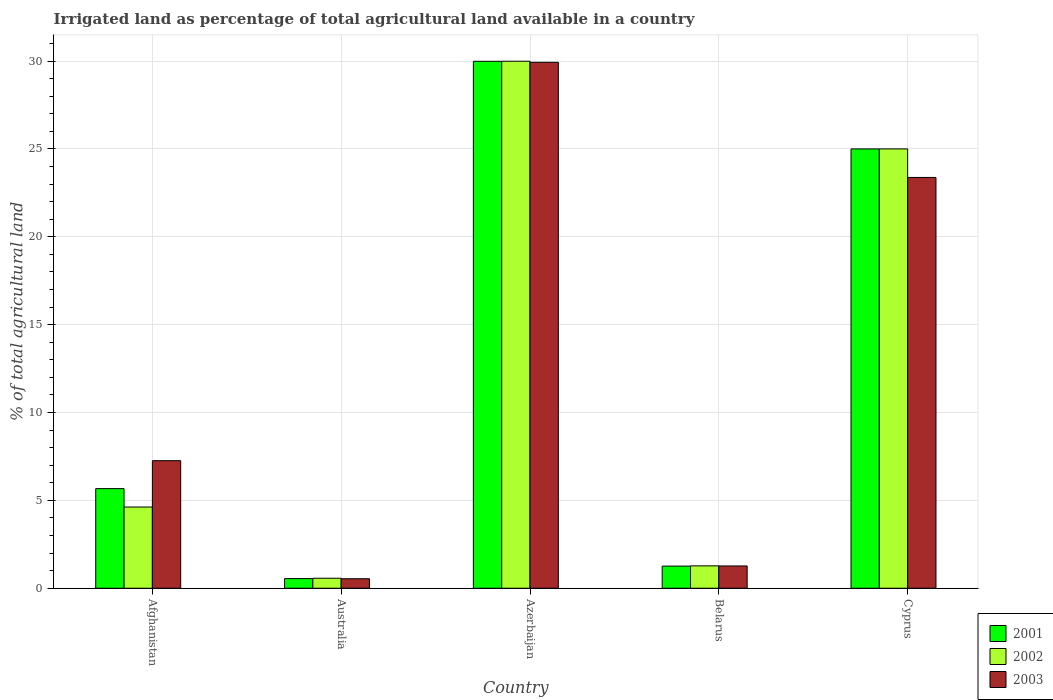Are the number of bars per tick equal to the number of legend labels?
Offer a terse response. Yes. Are the number of bars on each tick of the X-axis equal?
Your answer should be compact. Yes. What is the label of the 4th group of bars from the left?
Give a very brief answer. Belarus. What is the percentage of irrigated land in 2001 in Australia?
Your response must be concise. 0.55. Across all countries, what is the maximum percentage of irrigated land in 2003?
Provide a succinct answer. 29.93. Across all countries, what is the minimum percentage of irrigated land in 2003?
Provide a succinct answer. 0.54. In which country was the percentage of irrigated land in 2002 maximum?
Provide a succinct answer. Azerbaijan. In which country was the percentage of irrigated land in 2003 minimum?
Provide a succinct answer. Australia. What is the total percentage of irrigated land in 2001 in the graph?
Provide a short and direct response. 62.46. What is the difference between the percentage of irrigated land in 2002 in Azerbaijan and that in Belarus?
Keep it short and to the point. 28.72. What is the difference between the percentage of irrigated land in 2003 in Australia and the percentage of irrigated land in 2002 in Azerbaijan?
Keep it short and to the point. -29.45. What is the average percentage of irrigated land in 2001 per country?
Provide a succinct answer. 12.49. What is the difference between the percentage of irrigated land of/in 2002 and percentage of irrigated land of/in 2003 in Australia?
Your answer should be very brief. 0.03. What is the ratio of the percentage of irrigated land in 2003 in Azerbaijan to that in Cyprus?
Your answer should be very brief. 1.28. What is the difference between the highest and the second highest percentage of irrigated land in 2001?
Keep it short and to the point. 19.33. What is the difference between the highest and the lowest percentage of irrigated land in 2003?
Make the answer very short. 29.39. In how many countries, is the percentage of irrigated land in 2003 greater than the average percentage of irrigated land in 2003 taken over all countries?
Keep it short and to the point. 2. What does the 1st bar from the left in Belarus represents?
Offer a very short reply. 2001. What does the 3rd bar from the right in Cyprus represents?
Keep it short and to the point. 2001. Is it the case that in every country, the sum of the percentage of irrigated land in 2001 and percentage of irrigated land in 2002 is greater than the percentage of irrigated land in 2003?
Your answer should be compact. Yes. Are all the bars in the graph horizontal?
Offer a very short reply. No. Are the values on the major ticks of Y-axis written in scientific E-notation?
Your answer should be very brief. No. Does the graph contain grids?
Your response must be concise. Yes. How many legend labels are there?
Make the answer very short. 3. What is the title of the graph?
Offer a terse response. Irrigated land as percentage of total agricultural land available in a country. What is the label or title of the X-axis?
Provide a succinct answer. Country. What is the label or title of the Y-axis?
Keep it short and to the point. % of total agricultural land. What is the % of total agricultural land in 2001 in Afghanistan?
Offer a very short reply. 5.67. What is the % of total agricultural land of 2002 in Afghanistan?
Your answer should be compact. 4.62. What is the % of total agricultural land in 2003 in Afghanistan?
Ensure brevity in your answer.  7.26. What is the % of total agricultural land of 2001 in Australia?
Give a very brief answer. 0.55. What is the % of total agricultural land of 2002 in Australia?
Keep it short and to the point. 0.57. What is the % of total agricultural land of 2003 in Australia?
Your answer should be very brief. 0.54. What is the % of total agricultural land of 2001 in Azerbaijan?
Provide a succinct answer. 29.99. What is the % of total agricultural land of 2002 in Azerbaijan?
Provide a succinct answer. 29.99. What is the % of total agricultural land in 2003 in Azerbaijan?
Keep it short and to the point. 29.93. What is the % of total agricultural land of 2001 in Belarus?
Make the answer very short. 1.26. What is the % of total agricultural land in 2002 in Belarus?
Offer a very short reply. 1.27. What is the % of total agricultural land of 2003 in Belarus?
Give a very brief answer. 1.27. What is the % of total agricultural land of 2001 in Cyprus?
Offer a terse response. 25. What is the % of total agricultural land in 2003 in Cyprus?
Ensure brevity in your answer.  23.38. Across all countries, what is the maximum % of total agricultural land in 2001?
Provide a short and direct response. 29.99. Across all countries, what is the maximum % of total agricultural land in 2002?
Make the answer very short. 29.99. Across all countries, what is the maximum % of total agricultural land in 2003?
Provide a short and direct response. 29.93. Across all countries, what is the minimum % of total agricultural land of 2001?
Make the answer very short. 0.55. Across all countries, what is the minimum % of total agricultural land in 2002?
Provide a succinct answer. 0.57. Across all countries, what is the minimum % of total agricultural land in 2003?
Your answer should be very brief. 0.54. What is the total % of total agricultural land in 2001 in the graph?
Keep it short and to the point. 62.46. What is the total % of total agricultural land in 2002 in the graph?
Offer a terse response. 61.46. What is the total % of total agricultural land in 2003 in the graph?
Offer a very short reply. 62.37. What is the difference between the % of total agricultural land in 2001 in Afghanistan and that in Australia?
Offer a terse response. 5.12. What is the difference between the % of total agricultural land in 2002 in Afghanistan and that in Australia?
Your answer should be very brief. 4.05. What is the difference between the % of total agricultural land of 2003 in Afghanistan and that in Australia?
Offer a very short reply. 6.72. What is the difference between the % of total agricultural land in 2001 in Afghanistan and that in Azerbaijan?
Your answer should be compact. -24.32. What is the difference between the % of total agricultural land in 2002 in Afghanistan and that in Azerbaijan?
Give a very brief answer. -25.37. What is the difference between the % of total agricultural land of 2003 in Afghanistan and that in Azerbaijan?
Ensure brevity in your answer.  -22.67. What is the difference between the % of total agricultural land of 2001 in Afghanistan and that in Belarus?
Your answer should be very brief. 4.41. What is the difference between the % of total agricultural land in 2002 in Afghanistan and that in Belarus?
Your response must be concise. 3.35. What is the difference between the % of total agricultural land of 2003 in Afghanistan and that in Belarus?
Keep it short and to the point. 5.99. What is the difference between the % of total agricultural land of 2001 in Afghanistan and that in Cyprus?
Give a very brief answer. -19.33. What is the difference between the % of total agricultural land of 2002 in Afghanistan and that in Cyprus?
Offer a very short reply. -20.38. What is the difference between the % of total agricultural land in 2003 in Afghanistan and that in Cyprus?
Your response must be concise. -16.12. What is the difference between the % of total agricultural land of 2001 in Australia and that in Azerbaijan?
Offer a very short reply. -29.44. What is the difference between the % of total agricultural land of 2002 in Australia and that in Azerbaijan?
Provide a succinct answer. -29.42. What is the difference between the % of total agricultural land of 2003 in Australia and that in Azerbaijan?
Ensure brevity in your answer.  -29.39. What is the difference between the % of total agricultural land in 2001 in Australia and that in Belarus?
Your answer should be very brief. -0.71. What is the difference between the % of total agricultural land in 2002 in Australia and that in Belarus?
Your response must be concise. -0.7. What is the difference between the % of total agricultural land of 2003 in Australia and that in Belarus?
Ensure brevity in your answer.  -0.73. What is the difference between the % of total agricultural land in 2001 in Australia and that in Cyprus?
Your response must be concise. -24.45. What is the difference between the % of total agricultural land in 2002 in Australia and that in Cyprus?
Provide a succinct answer. -24.43. What is the difference between the % of total agricultural land in 2003 in Australia and that in Cyprus?
Make the answer very short. -22.84. What is the difference between the % of total agricultural land of 2001 in Azerbaijan and that in Belarus?
Offer a terse response. 28.73. What is the difference between the % of total agricultural land in 2002 in Azerbaijan and that in Belarus?
Give a very brief answer. 28.72. What is the difference between the % of total agricultural land in 2003 in Azerbaijan and that in Belarus?
Make the answer very short. 28.66. What is the difference between the % of total agricultural land in 2001 in Azerbaijan and that in Cyprus?
Offer a terse response. 4.99. What is the difference between the % of total agricultural land in 2002 in Azerbaijan and that in Cyprus?
Keep it short and to the point. 4.99. What is the difference between the % of total agricultural land in 2003 in Azerbaijan and that in Cyprus?
Your answer should be compact. 6.55. What is the difference between the % of total agricultural land in 2001 in Belarus and that in Cyprus?
Your response must be concise. -23.74. What is the difference between the % of total agricultural land of 2002 in Belarus and that in Cyprus?
Keep it short and to the point. -23.73. What is the difference between the % of total agricultural land of 2003 in Belarus and that in Cyprus?
Your answer should be very brief. -22.11. What is the difference between the % of total agricultural land in 2001 in Afghanistan and the % of total agricultural land in 2002 in Australia?
Provide a succinct answer. 5.1. What is the difference between the % of total agricultural land of 2001 in Afghanistan and the % of total agricultural land of 2003 in Australia?
Offer a very short reply. 5.13. What is the difference between the % of total agricultural land in 2002 in Afghanistan and the % of total agricultural land in 2003 in Australia?
Make the answer very short. 4.08. What is the difference between the % of total agricultural land in 2001 in Afghanistan and the % of total agricultural land in 2002 in Azerbaijan?
Ensure brevity in your answer.  -24.32. What is the difference between the % of total agricultural land of 2001 in Afghanistan and the % of total agricultural land of 2003 in Azerbaijan?
Provide a short and direct response. -24.26. What is the difference between the % of total agricultural land in 2002 in Afghanistan and the % of total agricultural land in 2003 in Azerbaijan?
Your answer should be compact. -25.31. What is the difference between the % of total agricultural land in 2001 in Afghanistan and the % of total agricultural land in 2002 in Belarus?
Ensure brevity in your answer.  4.39. What is the difference between the % of total agricultural land of 2001 in Afghanistan and the % of total agricultural land of 2003 in Belarus?
Your answer should be very brief. 4.4. What is the difference between the % of total agricultural land in 2002 in Afghanistan and the % of total agricultural land in 2003 in Belarus?
Provide a short and direct response. 3.35. What is the difference between the % of total agricultural land in 2001 in Afghanistan and the % of total agricultural land in 2002 in Cyprus?
Make the answer very short. -19.33. What is the difference between the % of total agricultural land in 2001 in Afghanistan and the % of total agricultural land in 2003 in Cyprus?
Provide a succinct answer. -17.71. What is the difference between the % of total agricultural land in 2002 in Afghanistan and the % of total agricultural land in 2003 in Cyprus?
Offer a very short reply. -18.75. What is the difference between the % of total agricultural land of 2001 in Australia and the % of total agricultural land of 2002 in Azerbaijan?
Give a very brief answer. -29.44. What is the difference between the % of total agricultural land in 2001 in Australia and the % of total agricultural land in 2003 in Azerbaijan?
Your answer should be compact. -29.38. What is the difference between the % of total agricultural land in 2002 in Australia and the % of total agricultural land in 2003 in Azerbaijan?
Your answer should be compact. -29.36. What is the difference between the % of total agricultural land of 2001 in Australia and the % of total agricultural land of 2002 in Belarus?
Provide a short and direct response. -0.72. What is the difference between the % of total agricultural land in 2001 in Australia and the % of total agricultural land in 2003 in Belarus?
Your answer should be very brief. -0.72. What is the difference between the % of total agricultural land in 2002 in Australia and the % of total agricultural land in 2003 in Belarus?
Your answer should be compact. -0.7. What is the difference between the % of total agricultural land in 2001 in Australia and the % of total agricultural land in 2002 in Cyprus?
Give a very brief answer. -24.45. What is the difference between the % of total agricultural land of 2001 in Australia and the % of total agricultural land of 2003 in Cyprus?
Provide a succinct answer. -22.83. What is the difference between the % of total agricultural land in 2002 in Australia and the % of total agricultural land in 2003 in Cyprus?
Ensure brevity in your answer.  -22.81. What is the difference between the % of total agricultural land in 2001 in Azerbaijan and the % of total agricultural land in 2002 in Belarus?
Make the answer very short. 28.71. What is the difference between the % of total agricultural land of 2001 in Azerbaijan and the % of total agricultural land of 2003 in Belarus?
Your answer should be compact. 28.72. What is the difference between the % of total agricultural land in 2002 in Azerbaijan and the % of total agricultural land in 2003 in Belarus?
Keep it short and to the point. 28.72. What is the difference between the % of total agricultural land of 2001 in Azerbaijan and the % of total agricultural land of 2002 in Cyprus?
Provide a short and direct response. 4.99. What is the difference between the % of total agricultural land in 2001 in Azerbaijan and the % of total agricultural land in 2003 in Cyprus?
Make the answer very short. 6.61. What is the difference between the % of total agricultural land of 2002 in Azerbaijan and the % of total agricultural land of 2003 in Cyprus?
Your answer should be very brief. 6.61. What is the difference between the % of total agricultural land in 2001 in Belarus and the % of total agricultural land in 2002 in Cyprus?
Your answer should be compact. -23.74. What is the difference between the % of total agricultural land of 2001 in Belarus and the % of total agricultural land of 2003 in Cyprus?
Offer a very short reply. -22.12. What is the difference between the % of total agricultural land of 2002 in Belarus and the % of total agricultural land of 2003 in Cyprus?
Provide a succinct answer. -22.1. What is the average % of total agricultural land in 2001 per country?
Your answer should be compact. 12.49. What is the average % of total agricultural land in 2002 per country?
Your answer should be compact. 12.29. What is the average % of total agricultural land in 2003 per country?
Provide a short and direct response. 12.47. What is the difference between the % of total agricultural land of 2001 and % of total agricultural land of 2002 in Afghanistan?
Give a very brief answer. 1.05. What is the difference between the % of total agricultural land in 2001 and % of total agricultural land in 2003 in Afghanistan?
Your response must be concise. -1.59. What is the difference between the % of total agricultural land of 2002 and % of total agricultural land of 2003 in Afghanistan?
Your response must be concise. -2.64. What is the difference between the % of total agricultural land of 2001 and % of total agricultural land of 2002 in Australia?
Your answer should be very brief. -0.02. What is the difference between the % of total agricultural land in 2001 and % of total agricultural land in 2003 in Australia?
Offer a very short reply. 0.01. What is the difference between the % of total agricultural land of 2002 and % of total agricultural land of 2003 in Australia?
Your answer should be compact. 0.03. What is the difference between the % of total agricultural land in 2001 and % of total agricultural land in 2002 in Azerbaijan?
Provide a short and direct response. -0. What is the difference between the % of total agricultural land of 2001 and % of total agricultural land of 2003 in Azerbaijan?
Provide a succinct answer. 0.06. What is the difference between the % of total agricultural land of 2002 and % of total agricultural land of 2003 in Azerbaijan?
Keep it short and to the point. 0.06. What is the difference between the % of total agricultural land of 2001 and % of total agricultural land of 2002 in Belarus?
Give a very brief answer. -0.01. What is the difference between the % of total agricultural land in 2001 and % of total agricultural land in 2003 in Belarus?
Ensure brevity in your answer.  -0.01. What is the difference between the % of total agricultural land of 2002 and % of total agricultural land of 2003 in Belarus?
Offer a very short reply. 0.01. What is the difference between the % of total agricultural land in 2001 and % of total agricultural land in 2003 in Cyprus?
Ensure brevity in your answer.  1.62. What is the difference between the % of total agricultural land in 2002 and % of total agricultural land in 2003 in Cyprus?
Provide a succinct answer. 1.62. What is the ratio of the % of total agricultural land of 2001 in Afghanistan to that in Australia?
Your answer should be compact. 10.31. What is the ratio of the % of total agricultural land in 2002 in Afghanistan to that in Australia?
Provide a succinct answer. 8.12. What is the ratio of the % of total agricultural land in 2003 in Afghanistan to that in Australia?
Offer a terse response. 13.42. What is the ratio of the % of total agricultural land of 2001 in Afghanistan to that in Azerbaijan?
Your answer should be very brief. 0.19. What is the ratio of the % of total agricultural land in 2002 in Afghanistan to that in Azerbaijan?
Provide a succinct answer. 0.15. What is the ratio of the % of total agricultural land of 2003 in Afghanistan to that in Azerbaijan?
Provide a short and direct response. 0.24. What is the ratio of the % of total agricultural land of 2001 in Afghanistan to that in Belarus?
Provide a short and direct response. 4.5. What is the ratio of the % of total agricultural land of 2002 in Afghanistan to that in Belarus?
Offer a very short reply. 3.63. What is the ratio of the % of total agricultural land in 2003 in Afghanistan to that in Belarus?
Offer a terse response. 5.72. What is the ratio of the % of total agricultural land of 2001 in Afghanistan to that in Cyprus?
Give a very brief answer. 0.23. What is the ratio of the % of total agricultural land in 2002 in Afghanistan to that in Cyprus?
Offer a very short reply. 0.18. What is the ratio of the % of total agricultural land of 2003 in Afghanistan to that in Cyprus?
Ensure brevity in your answer.  0.31. What is the ratio of the % of total agricultural land of 2001 in Australia to that in Azerbaijan?
Keep it short and to the point. 0.02. What is the ratio of the % of total agricultural land of 2002 in Australia to that in Azerbaijan?
Your response must be concise. 0.02. What is the ratio of the % of total agricultural land in 2003 in Australia to that in Azerbaijan?
Your answer should be compact. 0.02. What is the ratio of the % of total agricultural land of 2001 in Australia to that in Belarus?
Give a very brief answer. 0.44. What is the ratio of the % of total agricultural land in 2002 in Australia to that in Belarus?
Ensure brevity in your answer.  0.45. What is the ratio of the % of total agricultural land of 2003 in Australia to that in Belarus?
Make the answer very short. 0.43. What is the ratio of the % of total agricultural land of 2001 in Australia to that in Cyprus?
Ensure brevity in your answer.  0.02. What is the ratio of the % of total agricultural land in 2002 in Australia to that in Cyprus?
Provide a succinct answer. 0.02. What is the ratio of the % of total agricultural land in 2003 in Australia to that in Cyprus?
Give a very brief answer. 0.02. What is the ratio of the % of total agricultural land of 2001 in Azerbaijan to that in Belarus?
Make the answer very short. 23.8. What is the ratio of the % of total agricultural land in 2002 in Azerbaijan to that in Belarus?
Your answer should be compact. 23.54. What is the ratio of the % of total agricultural land of 2003 in Azerbaijan to that in Belarus?
Offer a very short reply. 23.59. What is the ratio of the % of total agricultural land of 2001 in Azerbaijan to that in Cyprus?
Your answer should be very brief. 1.2. What is the ratio of the % of total agricultural land in 2002 in Azerbaijan to that in Cyprus?
Offer a terse response. 1.2. What is the ratio of the % of total agricultural land of 2003 in Azerbaijan to that in Cyprus?
Your answer should be compact. 1.28. What is the ratio of the % of total agricultural land of 2001 in Belarus to that in Cyprus?
Offer a terse response. 0.05. What is the ratio of the % of total agricultural land in 2002 in Belarus to that in Cyprus?
Your answer should be compact. 0.05. What is the ratio of the % of total agricultural land in 2003 in Belarus to that in Cyprus?
Provide a succinct answer. 0.05. What is the difference between the highest and the second highest % of total agricultural land of 2001?
Make the answer very short. 4.99. What is the difference between the highest and the second highest % of total agricultural land of 2002?
Give a very brief answer. 4.99. What is the difference between the highest and the second highest % of total agricultural land of 2003?
Make the answer very short. 6.55. What is the difference between the highest and the lowest % of total agricultural land of 2001?
Ensure brevity in your answer.  29.44. What is the difference between the highest and the lowest % of total agricultural land in 2002?
Give a very brief answer. 29.42. What is the difference between the highest and the lowest % of total agricultural land in 2003?
Keep it short and to the point. 29.39. 